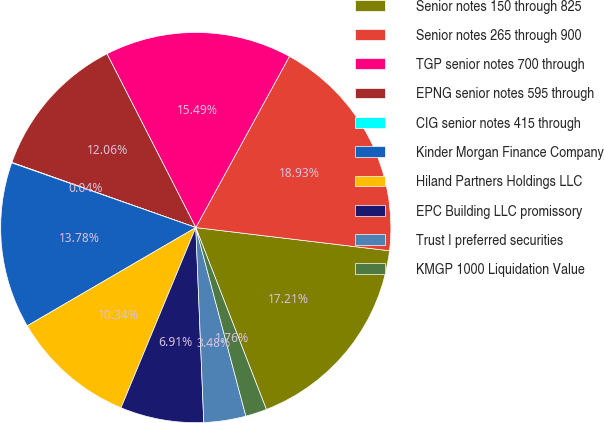<chart> <loc_0><loc_0><loc_500><loc_500><pie_chart><fcel>Senior notes 150 through 825<fcel>Senior notes 265 through 900<fcel>TGP senior notes 700 through<fcel>EPNG senior notes 595 through<fcel>CIG senior notes 415 through<fcel>Kinder Morgan Finance Company<fcel>Hiland Partners Holdings LLC<fcel>EPC Building LLC promissory<fcel>Trust I preferred securities<fcel>KMGP 1000 Liquidation Value<nl><fcel>17.21%<fcel>18.93%<fcel>15.49%<fcel>12.06%<fcel>0.04%<fcel>13.78%<fcel>10.34%<fcel>6.91%<fcel>3.48%<fcel>1.76%<nl></chart> 